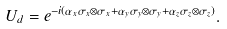<formula> <loc_0><loc_0><loc_500><loc_500>U _ { d } = e ^ { - i ( \alpha _ { x } \sigma _ { x } \otimes \sigma _ { x } + \alpha _ { y } \sigma _ { y } \otimes \sigma _ { y } + \alpha _ { z } \sigma _ { z } \otimes \sigma _ { z } ) } .</formula> 